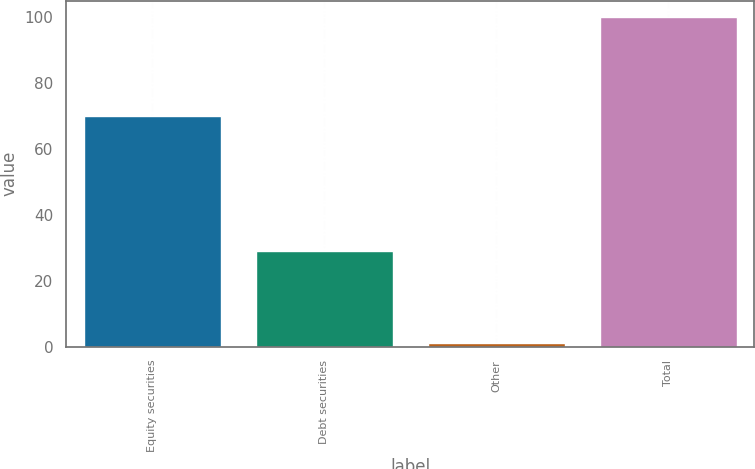<chart> <loc_0><loc_0><loc_500><loc_500><bar_chart><fcel>Equity securities<fcel>Debt securities<fcel>Other<fcel>Total<nl><fcel>70<fcel>29<fcel>1<fcel>100<nl></chart> 